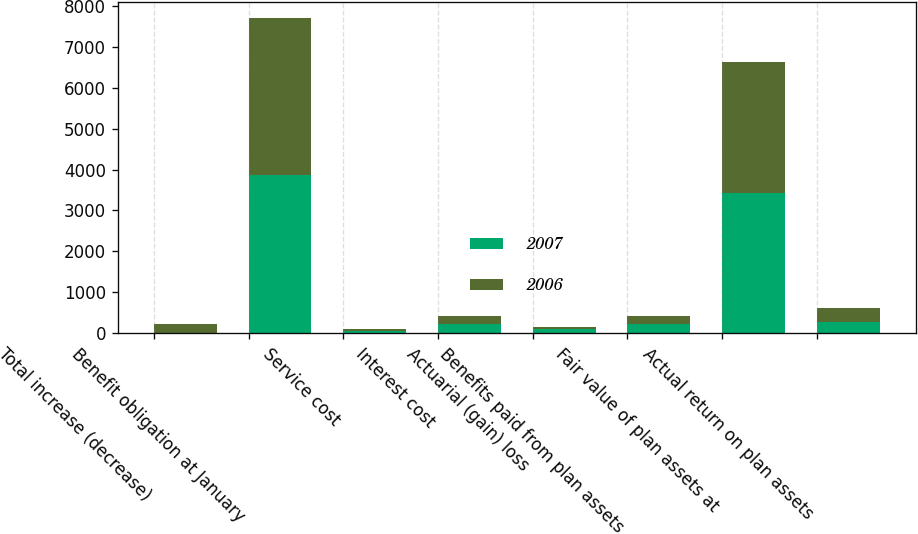Convert chart to OTSL. <chart><loc_0><loc_0><loc_500><loc_500><stacked_bar_chart><ecel><fcel>Total increase (decrease)<fcel>Benefit obligation at January<fcel>Service cost<fcel>Interest cost<fcel>Actuarial (gain) loss<fcel>Benefits paid from plan assets<fcel>Fair value of plan assets at<fcel>Actual return on plan assets<nl><fcel>2007<fcel>11<fcel>3861<fcel>49<fcel>214<fcel>104<fcel>214<fcel>3426<fcel>270<nl><fcel>2006<fcel>219<fcel>3842<fcel>53<fcel>210<fcel>59<fcel>219<fcel>3200<fcel>342<nl></chart> 